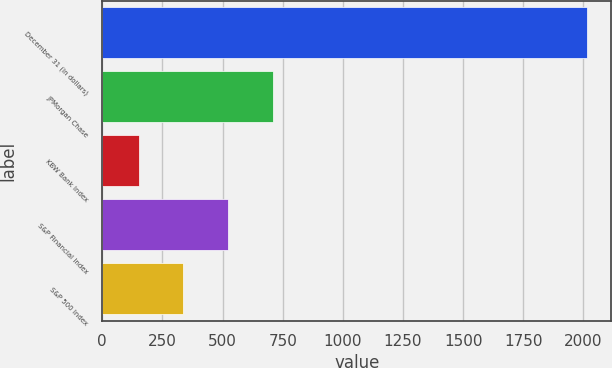<chart> <loc_0><loc_0><loc_500><loc_500><bar_chart><fcel>December 31 (in dollars)<fcel>JPMorgan Chase<fcel>KBW Bank Index<fcel>S&P Financial Index<fcel>S&P 500 Index<nl><fcel>2015<fcel>710.47<fcel>151.39<fcel>524.11<fcel>337.75<nl></chart> 